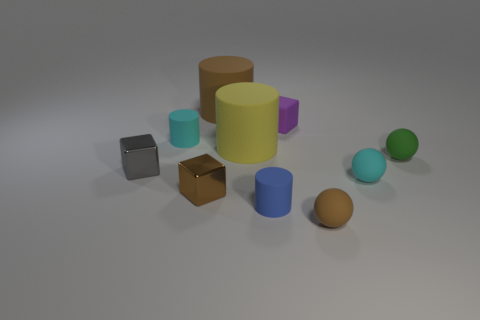Subtract all cylinders. How many objects are left? 6 Subtract 0 green cylinders. How many objects are left? 10 Subtract all metallic cubes. Subtract all tiny cyan cylinders. How many objects are left? 7 Add 4 rubber spheres. How many rubber spheres are left? 7 Add 6 tiny brown matte balls. How many tiny brown matte balls exist? 7 